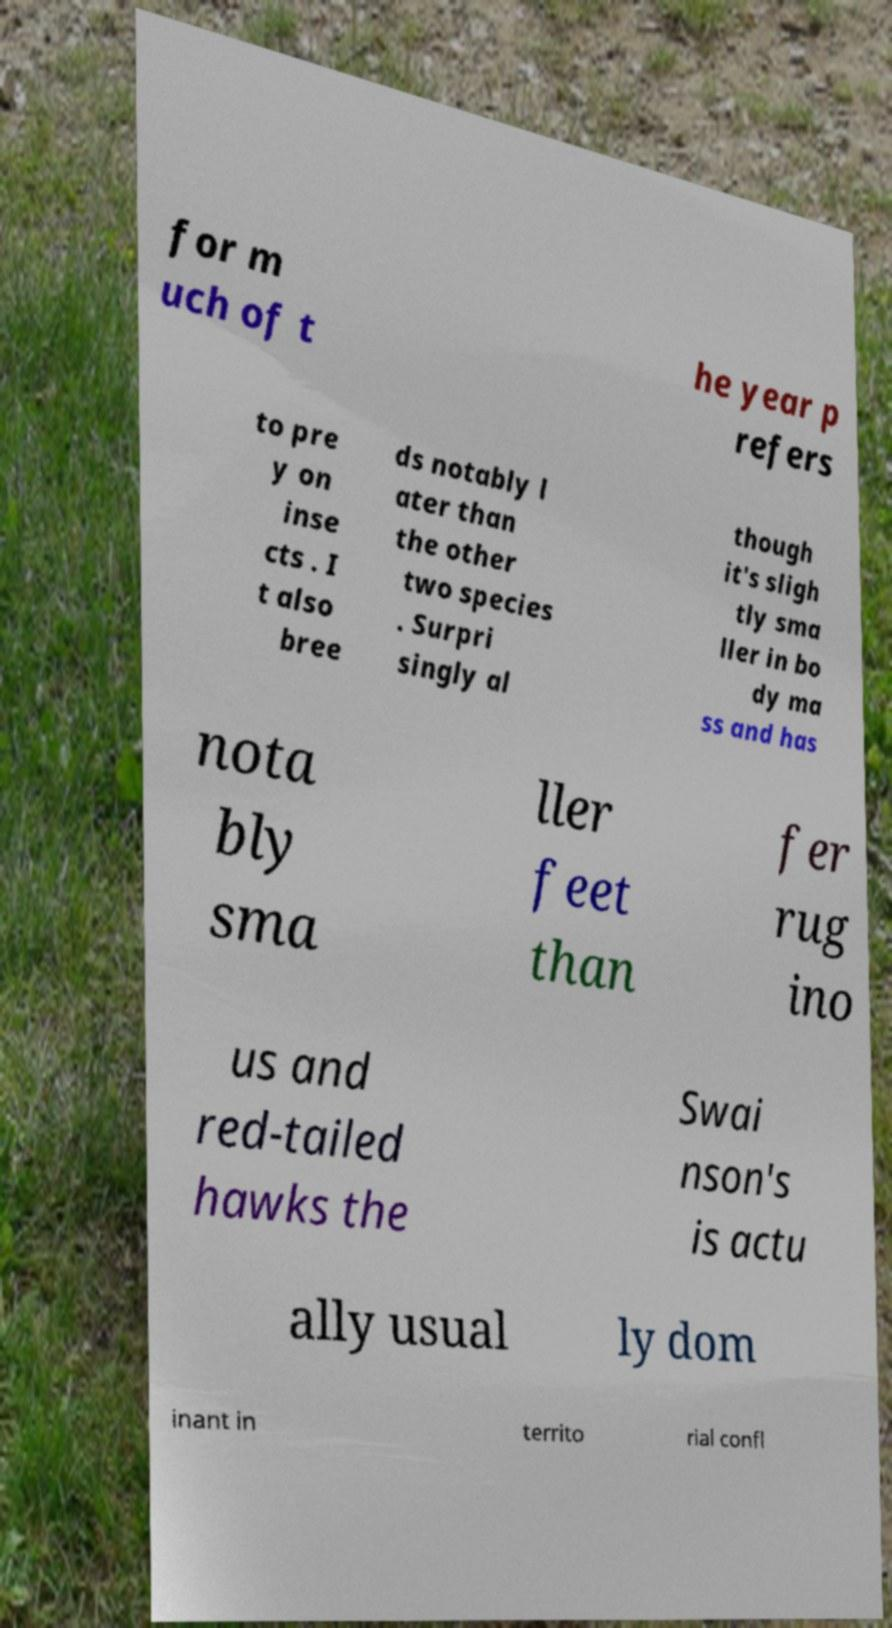Can you read and provide the text displayed in the image?This photo seems to have some interesting text. Can you extract and type it out for me? for m uch of t he year p refers to pre y on inse cts . I t also bree ds notably l ater than the other two species . Surpri singly al though it's sligh tly sma ller in bo dy ma ss and has nota bly sma ller feet than fer rug ino us and red-tailed hawks the Swai nson's is actu ally usual ly dom inant in territo rial confl 